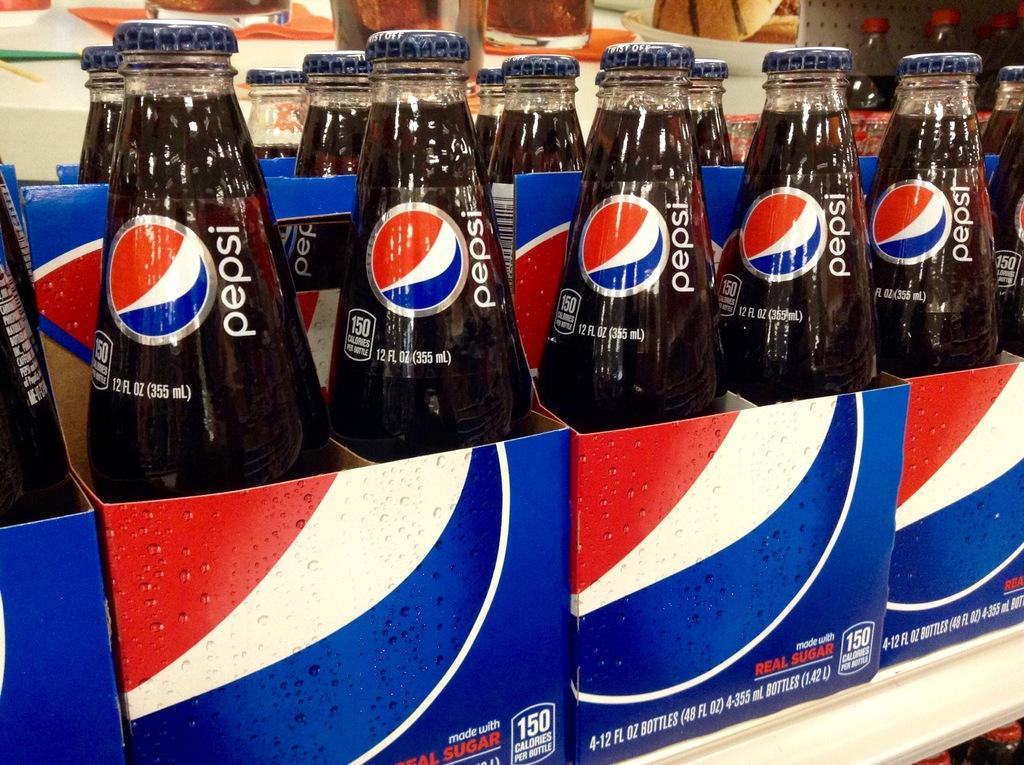What type of product is contained in the bottles in the image? The drink bottles have a Pepsi label, indicating that they contain Pepsi. How are the drink bottles packaged in the image? The drink bottles are in cardboard boxes. How many cakes are being tested with the spoon in the image? There are no cakes or spoons present in the image. 